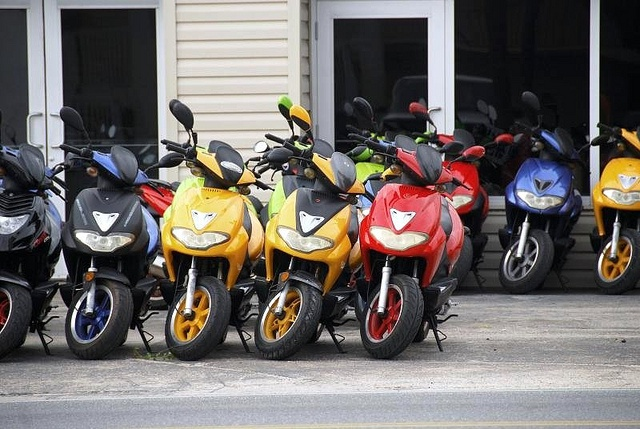Describe the objects in this image and their specific colors. I can see motorcycle in gray, black, khaki, and ivory tones, motorcycle in gray, black, salmon, and maroon tones, motorcycle in gray, black, white, and khaki tones, motorcycle in gray, black, lightgray, and darkgray tones, and motorcycle in gray, black, and navy tones in this image. 